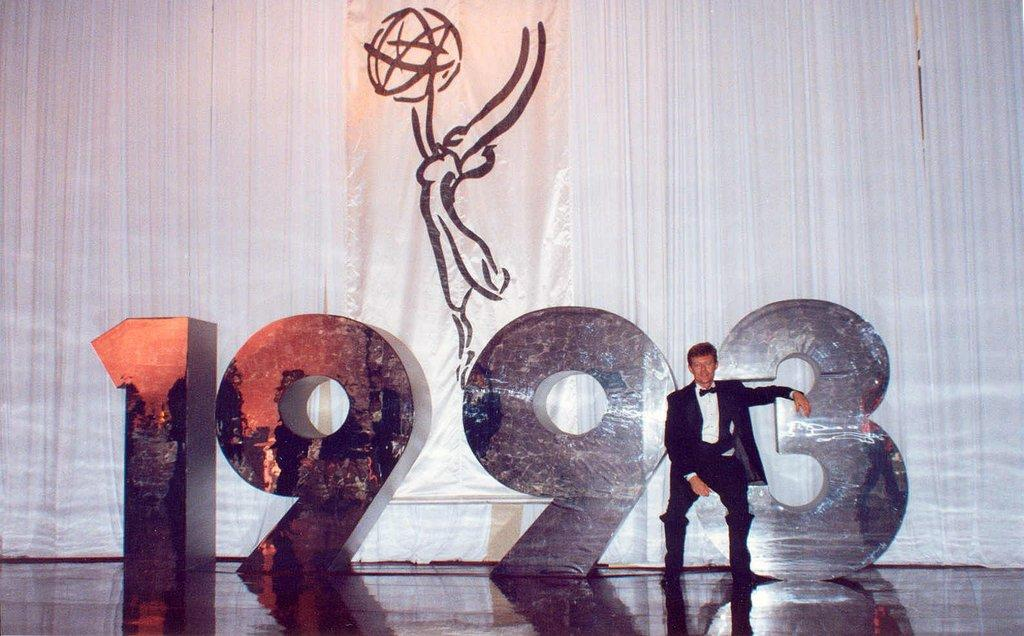Who is present in the image? There is a man in the image. Where is the man located in the image? The man is on the right side of the image. What is the man wearing in the image? The man is wearing a suit, a shirt, a tie, and trousers. What can be seen in the background of the image? There are posters, curtains, and numbers in the background of the image. What is visible at the bottom of the image? There is a floor visible in the image. What type of prison can be seen in the background of the image? There is no prison present in the image; the background features posters, curtains, and numbers. 